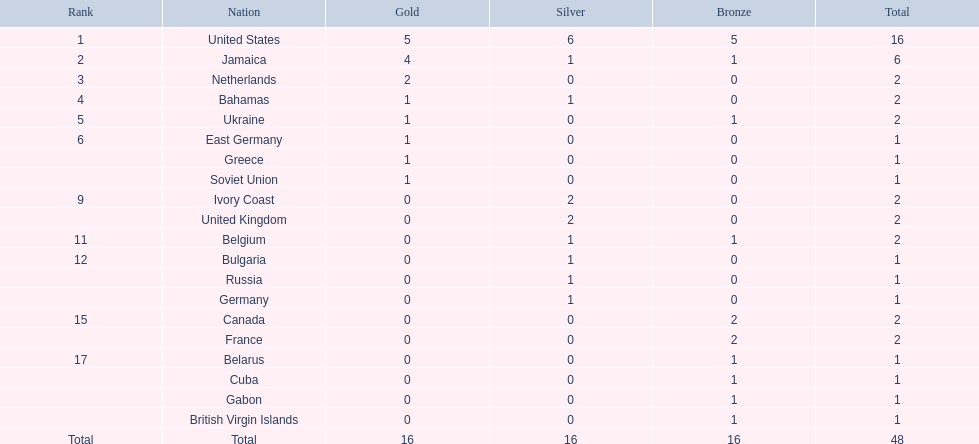Which nations participated in the 60 meters contest? United States, Jamaica, Netherlands, Bahamas, Ukraine, East Germany, Greece, Soviet Union, Ivory Coast, United Kingdom, Belgium, Bulgaria, Russia, Germany, Canada, France, Belarus, Cuba, Gabon, British Virgin Islands. And how many gold awards did they earn? 5, 4, 2, 1, 1, 1, 1, 1, 0, 0, 0, 0, 0, 0, 0, 0, 0, 0, 0, 0. Of those nations, which secured the second highest number of gold awards? Jamaica. 